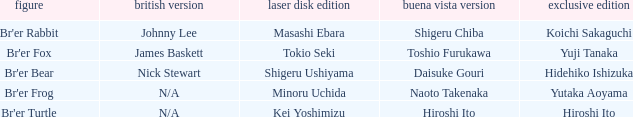What is the special edition for the english version of james baskett? Yuji Tanaka. 